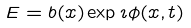Convert formula to latex. <formula><loc_0><loc_0><loc_500><loc_500>E = b ( x ) \exp \imath \phi ( x , t )</formula> 